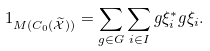Convert formula to latex. <formula><loc_0><loc_0><loc_500><loc_500>1 _ { M ( C _ { 0 } ( \widetilde { \mathcal { X } } ) ) } = \sum _ { g \in G } \sum _ { i \in I } g \xi ^ { * } _ { i } g \xi _ { i } .</formula> 